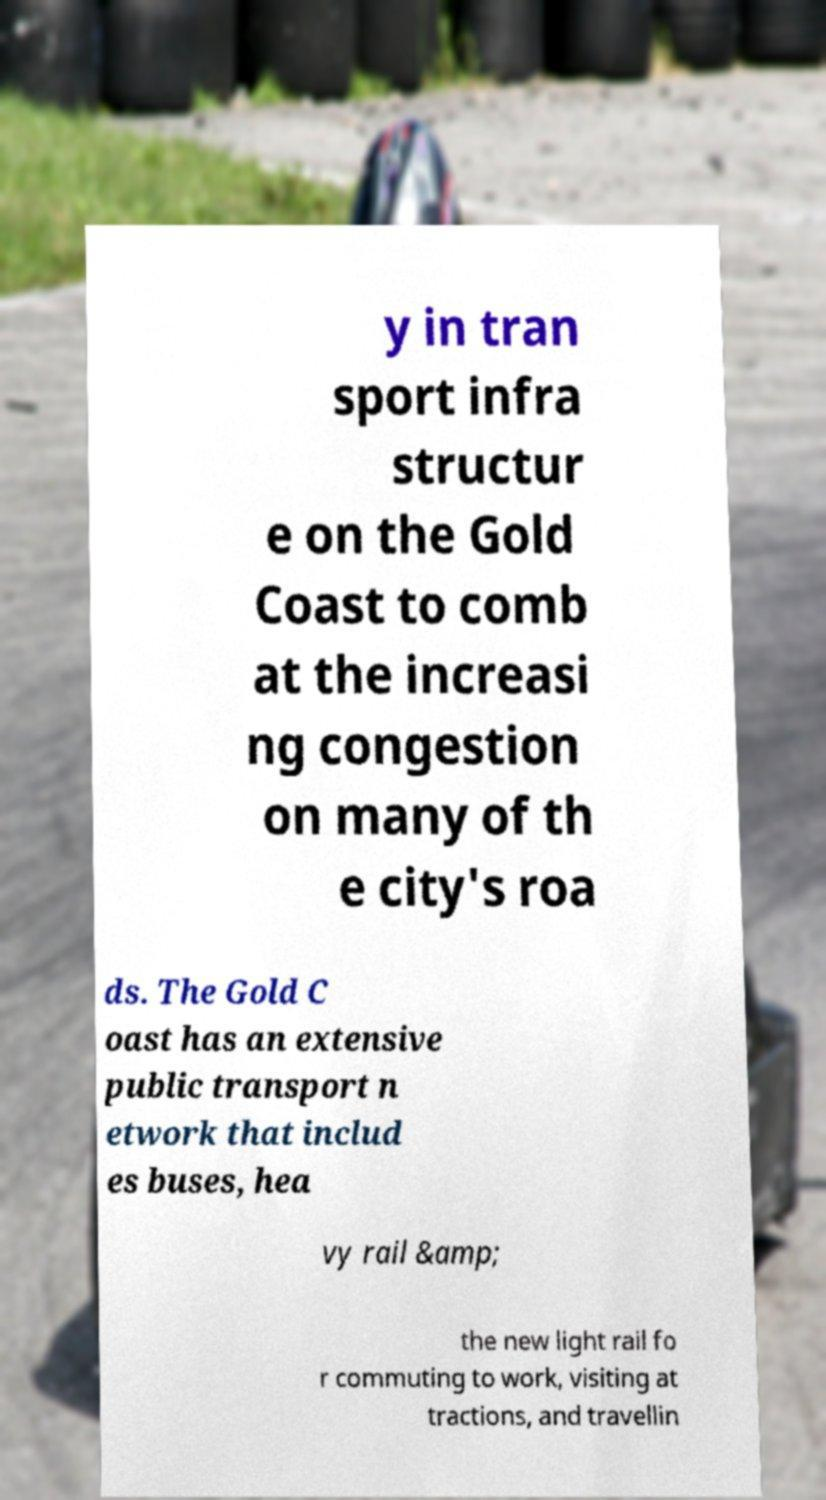There's text embedded in this image that I need extracted. Can you transcribe it verbatim? y in tran sport infra structur e on the Gold Coast to comb at the increasi ng congestion on many of th e city's roa ds. The Gold C oast has an extensive public transport n etwork that includ es buses, hea vy rail &amp; the new light rail fo r commuting to work, visiting at tractions, and travellin 